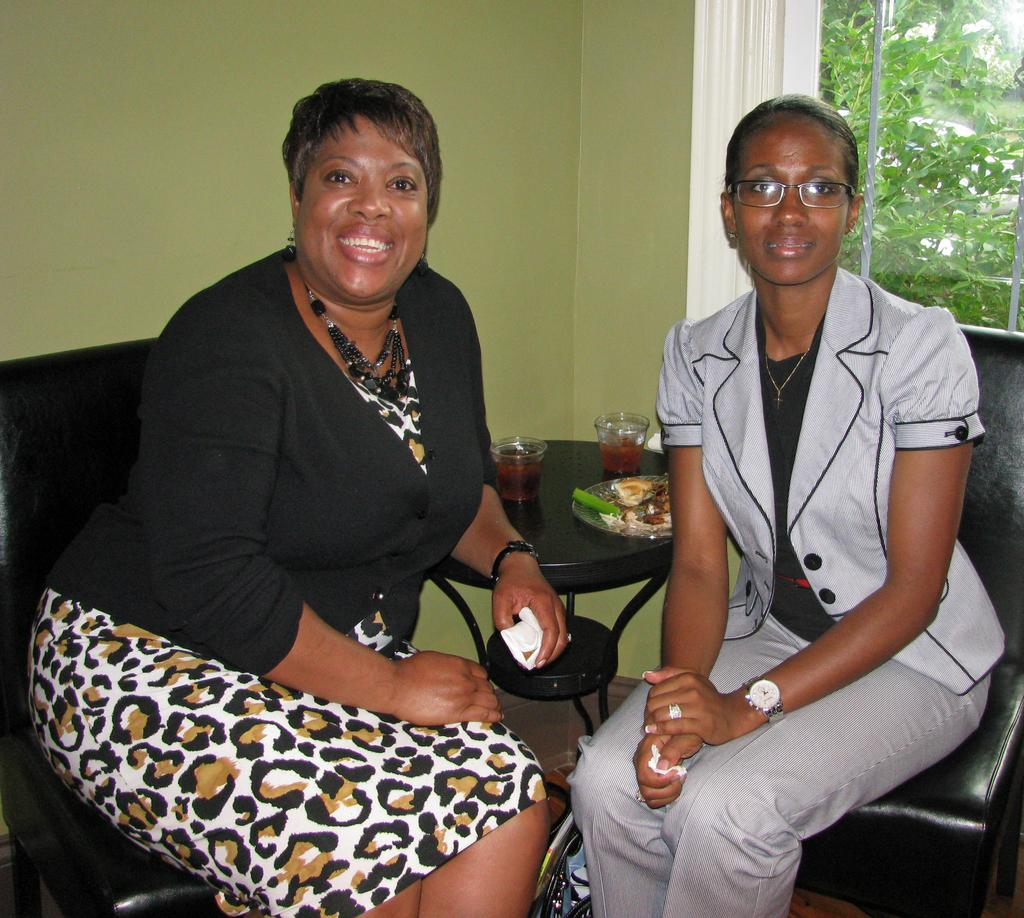How many women are in the image? There are two women in the image. What are the women doing in the image? The women are seated and smiling. What objects can be seen on the table in the image? There are glasses and a plate on the table. What can be seen in the background of the image? There are trees in the background of the image. What rule is being enforced by the women in the image? There is no indication in the image that the women are enforcing any rules. What type of prose can be seen on the plate in the image? There is no prose visible on the plate in the image; it is a physical object, not a written work. 